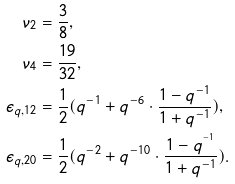<formula> <loc_0><loc_0><loc_500><loc_500>\nu _ { 2 } & = \frac { 3 } { 8 } , \\ \nu _ { 4 } & = \frac { 1 9 } { 3 2 } , \\ \epsilon _ { q , 1 2 } & = \frac { 1 } { 2 } ( q ^ { - 1 } + q ^ { - 6 } \cdot \frac { 1 - q ^ { - 1 } } { 1 + q ^ { - 1 } } ) , \\ \epsilon _ { q , 2 0 } & = \frac { 1 } { 2 } ( q ^ { - 2 } + q ^ { - 1 0 } \cdot \frac { 1 - q ^ { ^ { - 1 } } } { 1 + q ^ { - 1 } } ) .</formula> 